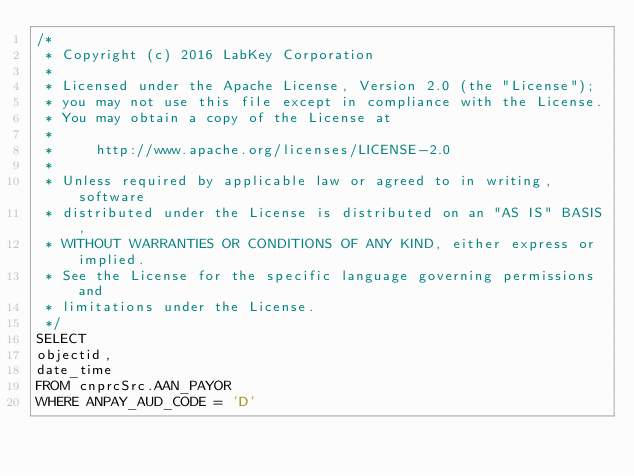<code> <loc_0><loc_0><loc_500><loc_500><_SQL_>/*
 * Copyright (c) 2016 LabKey Corporation
 *
 * Licensed under the Apache License, Version 2.0 (the "License");
 * you may not use this file except in compliance with the License.
 * You may obtain a copy of the License at
 *
 *     http://www.apache.org/licenses/LICENSE-2.0
 *
 * Unless required by applicable law or agreed to in writing, software
 * distributed under the License is distributed on an "AS IS" BASIS,
 * WITHOUT WARRANTIES OR CONDITIONS OF ANY KIND, either express or implied.
 * See the License for the specific language governing permissions and
 * limitations under the License.
 */
SELECT
objectid,
date_time
FROM cnprcSrc.AAN_PAYOR
WHERE ANPAY_AUD_CODE = 'D'
</code> 